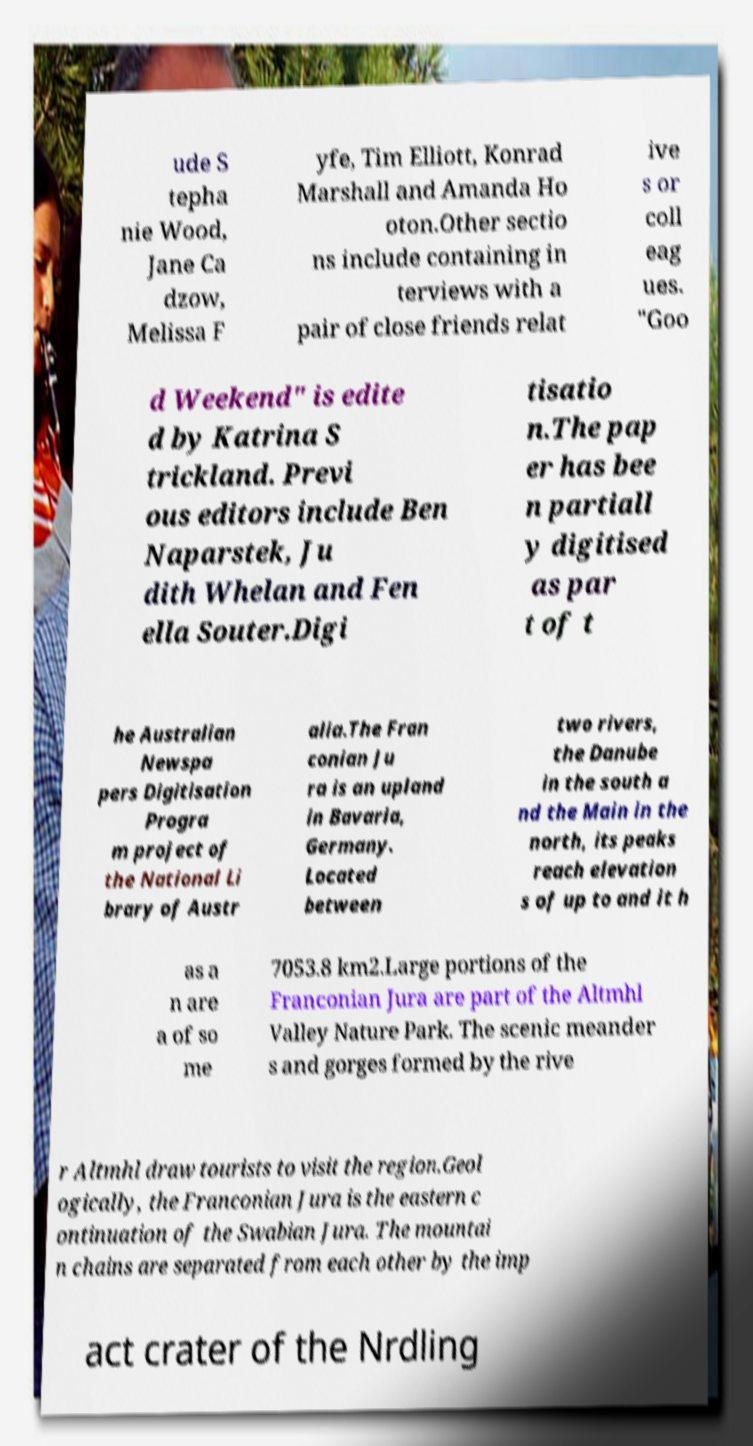I need the written content from this picture converted into text. Can you do that? ude S tepha nie Wood, Jane Ca dzow, Melissa F yfe, Tim Elliott, Konrad Marshall and Amanda Ho oton.Other sectio ns include containing in terviews with a pair of close friends relat ive s or coll eag ues. "Goo d Weekend" is edite d by Katrina S trickland. Previ ous editors include Ben Naparstek, Ju dith Whelan and Fen ella Souter.Digi tisatio n.The pap er has bee n partiall y digitised as par t of t he Australian Newspa pers Digitisation Progra m project of the National Li brary of Austr alia.The Fran conian Ju ra is an upland in Bavaria, Germany. Located between two rivers, the Danube in the south a nd the Main in the north, its peaks reach elevation s of up to and it h as a n are a of so me 7053.8 km2.Large portions of the Franconian Jura are part of the Altmhl Valley Nature Park. The scenic meander s and gorges formed by the rive r Altmhl draw tourists to visit the region.Geol ogically, the Franconian Jura is the eastern c ontinuation of the Swabian Jura. The mountai n chains are separated from each other by the imp act crater of the Nrdling 